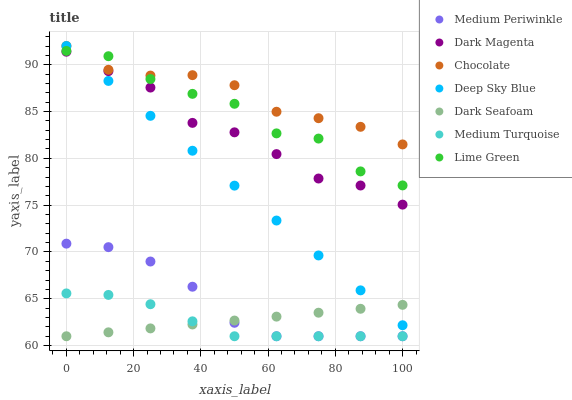Does Medium Turquoise have the minimum area under the curve?
Answer yes or no. Yes. Does Chocolate have the maximum area under the curve?
Answer yes or no. Yes. Does Medium Periwinkle have the minimum area under the curve?
Answer yes or no. No. Does Medium Periwinkle have the maximum area under the curve?
Answer yes or no. No. Is Dark Seafoam the smoothest?
Answer yes or no. Yes. Is Lime Green the roughest?
Answer yes or no. Yes. Is Medium Periwinkle the smoothest?
Answer yes or no. No. Is Medium Periwinkle the roughest?
Answer yes or no. No. Does Medium Periwinkle have the lowest value?
Answer yes or no. Yes. Does Chocolate have the lowest value?
Answer yes or no. No. Does Deep Sky Blue have the highest value?
Answer yes or no. Yes. Does Medium Periwinkle have the highest value?
Answer yes or no. No. Is Medium Periwinkle less than Deep Sky Blue?
Answer yes or no. Yes. Is Lime Green greater than Dark Seafoam?
Answer yes or no. Yes. Does Deep Sky Blue intersect Dark Magenta?
Answer yes or no. Yes. Is Deep Sky Blue less than Dark Magenta?
Answer yes or no. No. Is Deep Sky Blue greater than Dark Magenta?
Answer yes or no. No. Does Medium Periwinkle intersect Deep Sky Blue?
Answer yes or no. No. 